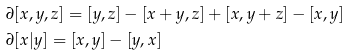Convert formula to latex. <formula><loc_0><loc_0><loc_500><loc_500>& \partial [ x , y , z ] = [ y , z ] - [ x + y , z ] + [ x , y + z ] - [ x , y ] \\ & \partial [ x | y ] = [ x , y ] - [ y , x ]</formula> 